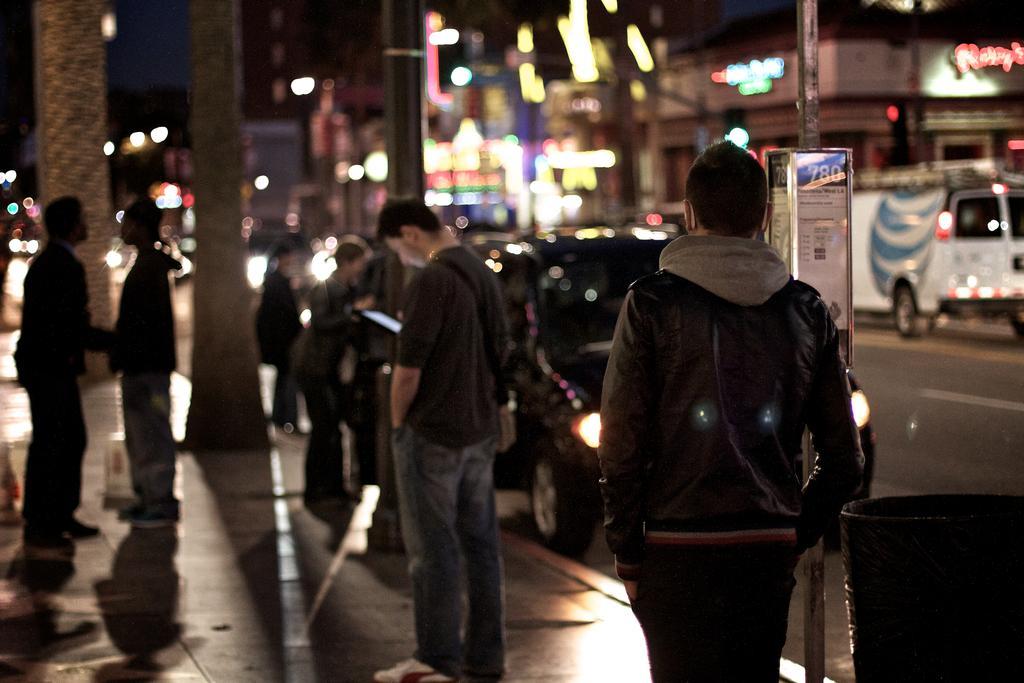Could you give a brief overview of what you see in this image? In this image we can see many people. On the right side there is a bin. Also there are vehicles on the road. In the background there are lights. And it is blurry in the background. And there is a board on a pillar. 